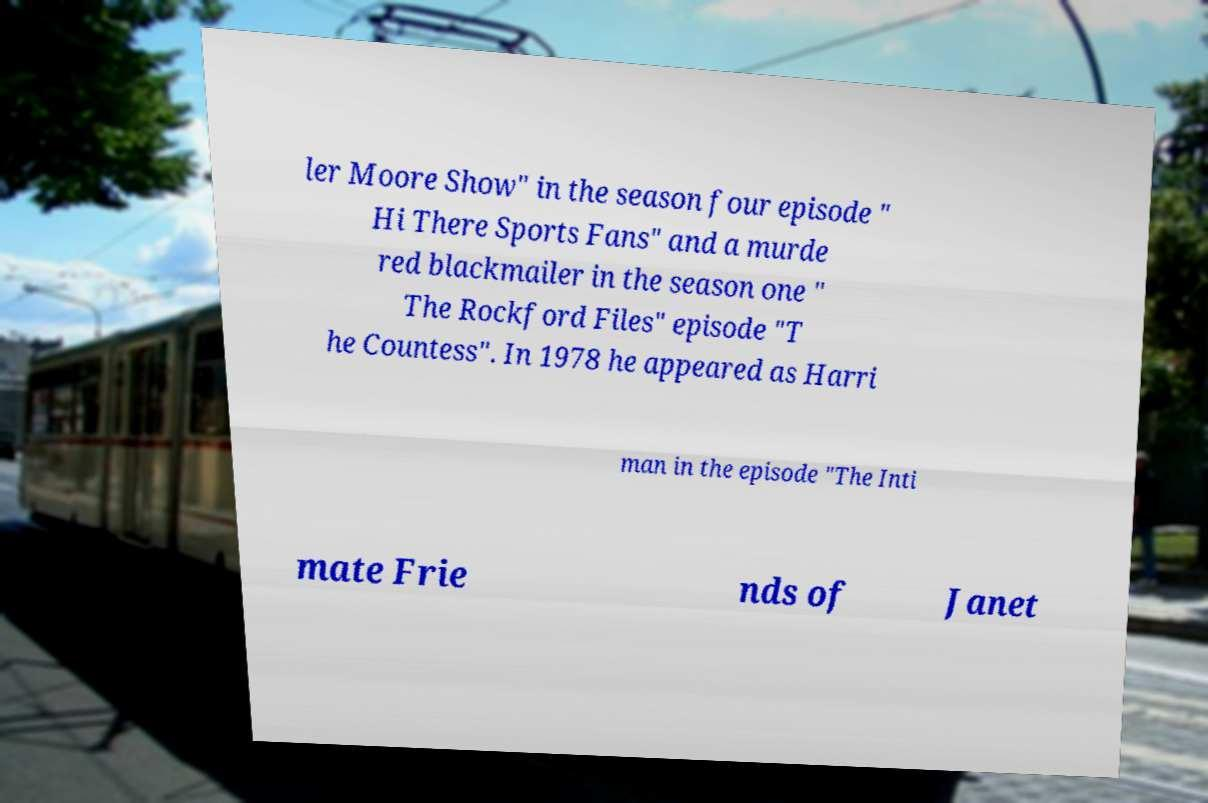Please identify and transcribe the text found in this image. ler Moore Show" in the season four episode " Hi There Sports Fans" and a murde red blackmailer in the season one " The Rockford Files" episode "T he Countess". In 1978 he appeared as Harri man in the episode "The Inti mate Frie nds of Janet 